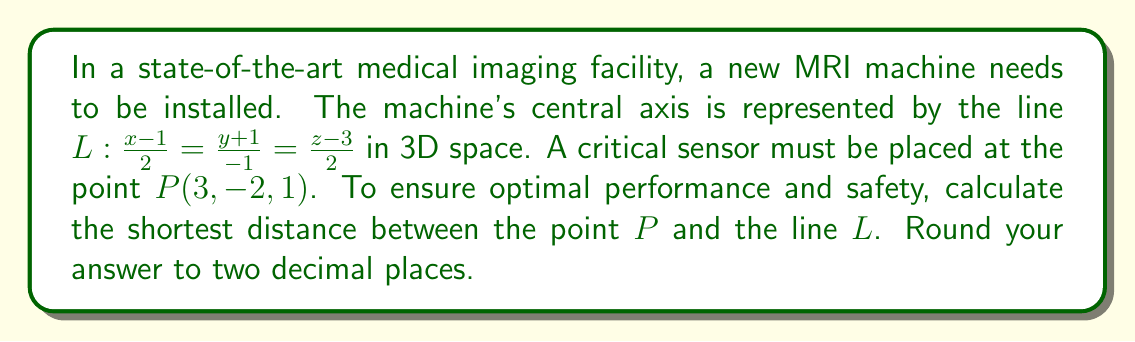Give your solution to this math problem. To find the shortest distance between a point and a line in 3D space, we'll follow these steps:

1) The general formula for the distance $d$ between a point $(x_0, y_0, z_0)$ and a line $\frac{x-x_1}{a} = \frac{y-y_1}{b} = \frac{z-z_1}{c}$ is:

   $$d = \frac{\sqrt{|(b(z_0-z_1) - c(y_0-y_1))^2 + (c(x_0-x_1) - a(z_0-z_1))^2 + (a(y_0-y_1) - b(x_0-x_1))^2|}{\sqrt{a^2 + b^2 + c^2}}$$

2) In our case:
   $(x_0, y_0, z_0) = (3, -2, 1)$ (the point $P$)
   $(x_1, y_1, z_1) = (1, -1, 3)$ (a point on the line $L$)
   $(a, b, c) = (2, -1, 2)$ (the direction vector of line $L$)

3) Let's substitute these values into the formula:

   $$d = \frac{\sqrt{|(-1(1-3) - 2(-2+1))^2 + (2(3-1) - 2(1-3))^2 + (2(-2+1) - (-1)(3-1))^2|}{\sqrt{2^2 + (-1)^2 + 2^2}}$$

4) Simplify the numerator:
   $$d = \frac{\sqrt{|(-1(-2) - 2(-1))^2 + (2(2) - 2(-2))^2 + (2(-1) - (-1)(2))^2|}{\sqrt{4 + 1 + 4}}$$
   
   $$d = \frac{\sqrt{|(2 + 2)^2 + (4 + 4)^2 + (-2 - 2)^2|}{\sqrt{9}}$$

5) Simplify further:
   $$d = \frac{\sqrt{4^2 + 8^2 + (-4)^2}}{3}$$
   
   $$d = \frac{\sqrt{16 + 64 + 16}}{3} = \frac{\sqrt{96}}{3}$$

6) Simplify the square root:
   $$d = \frac{4\sqrt{6}}{3}$$

7) Calculate the decimal approximation and round to two decimal places:
   $$d \approx 3.27$$
Answer: $3.27$ units 